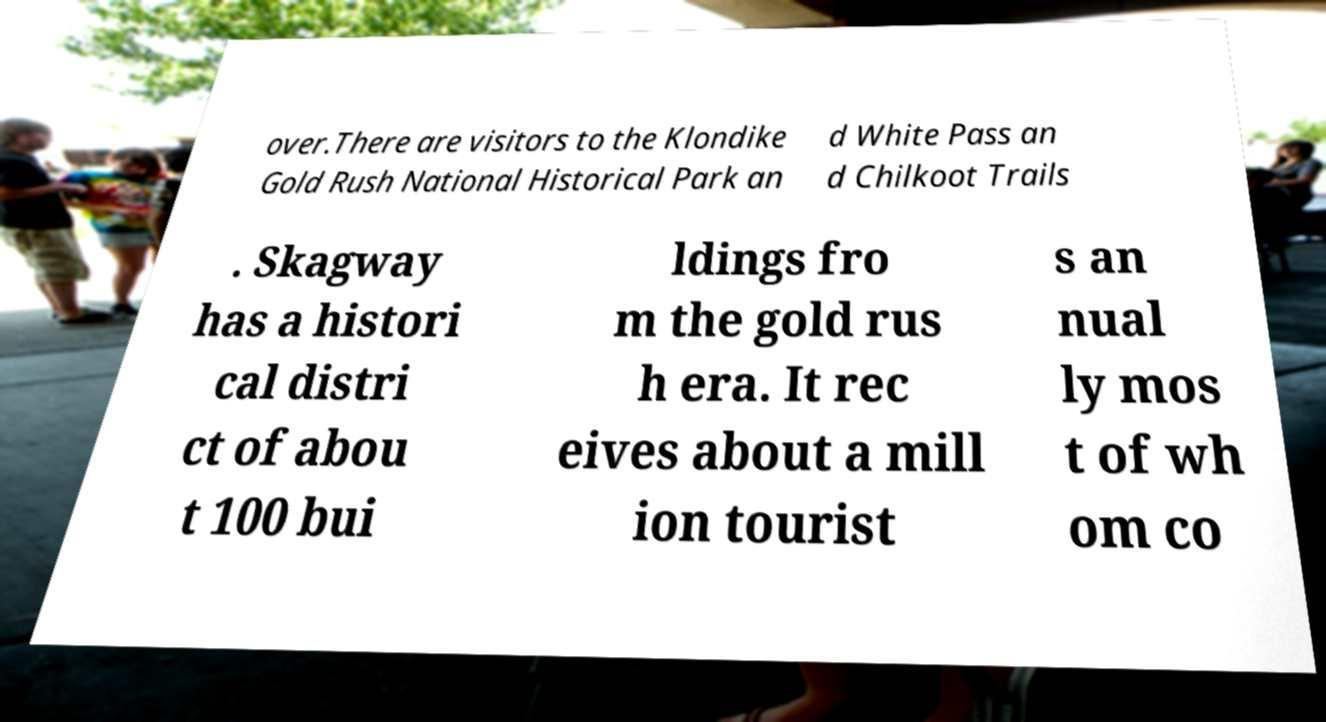What messages or text are displayed in this image? I need them in a readable, typed format. over.There are visitors to the Klondike Gold Rush National Historical Park an d White Pass an d Chilkoot Trails . Skagway has a histori cal distri ct of abou t 100 bui ldings fro m the gold rus h era. It rec eives about a mill ion tourist s an nual ly mos t of wh om co 